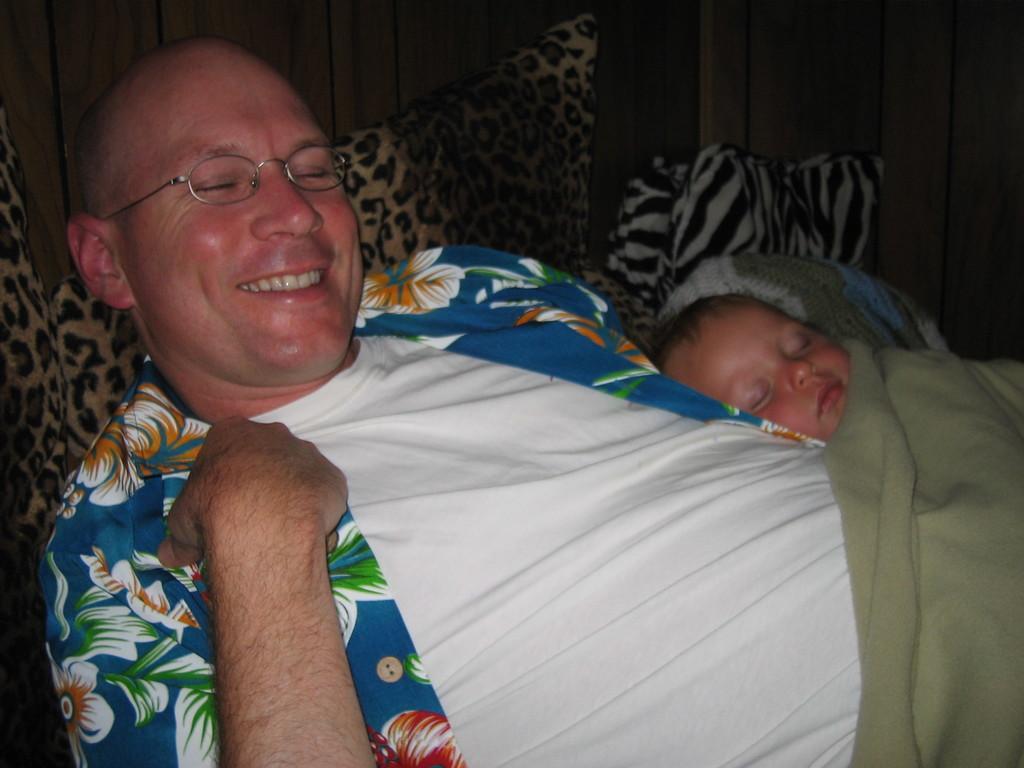Please provide a concise description of this image. In this image I can see a person and baby sleeping. I can see a green color blanket,pillows and wooden wall. 